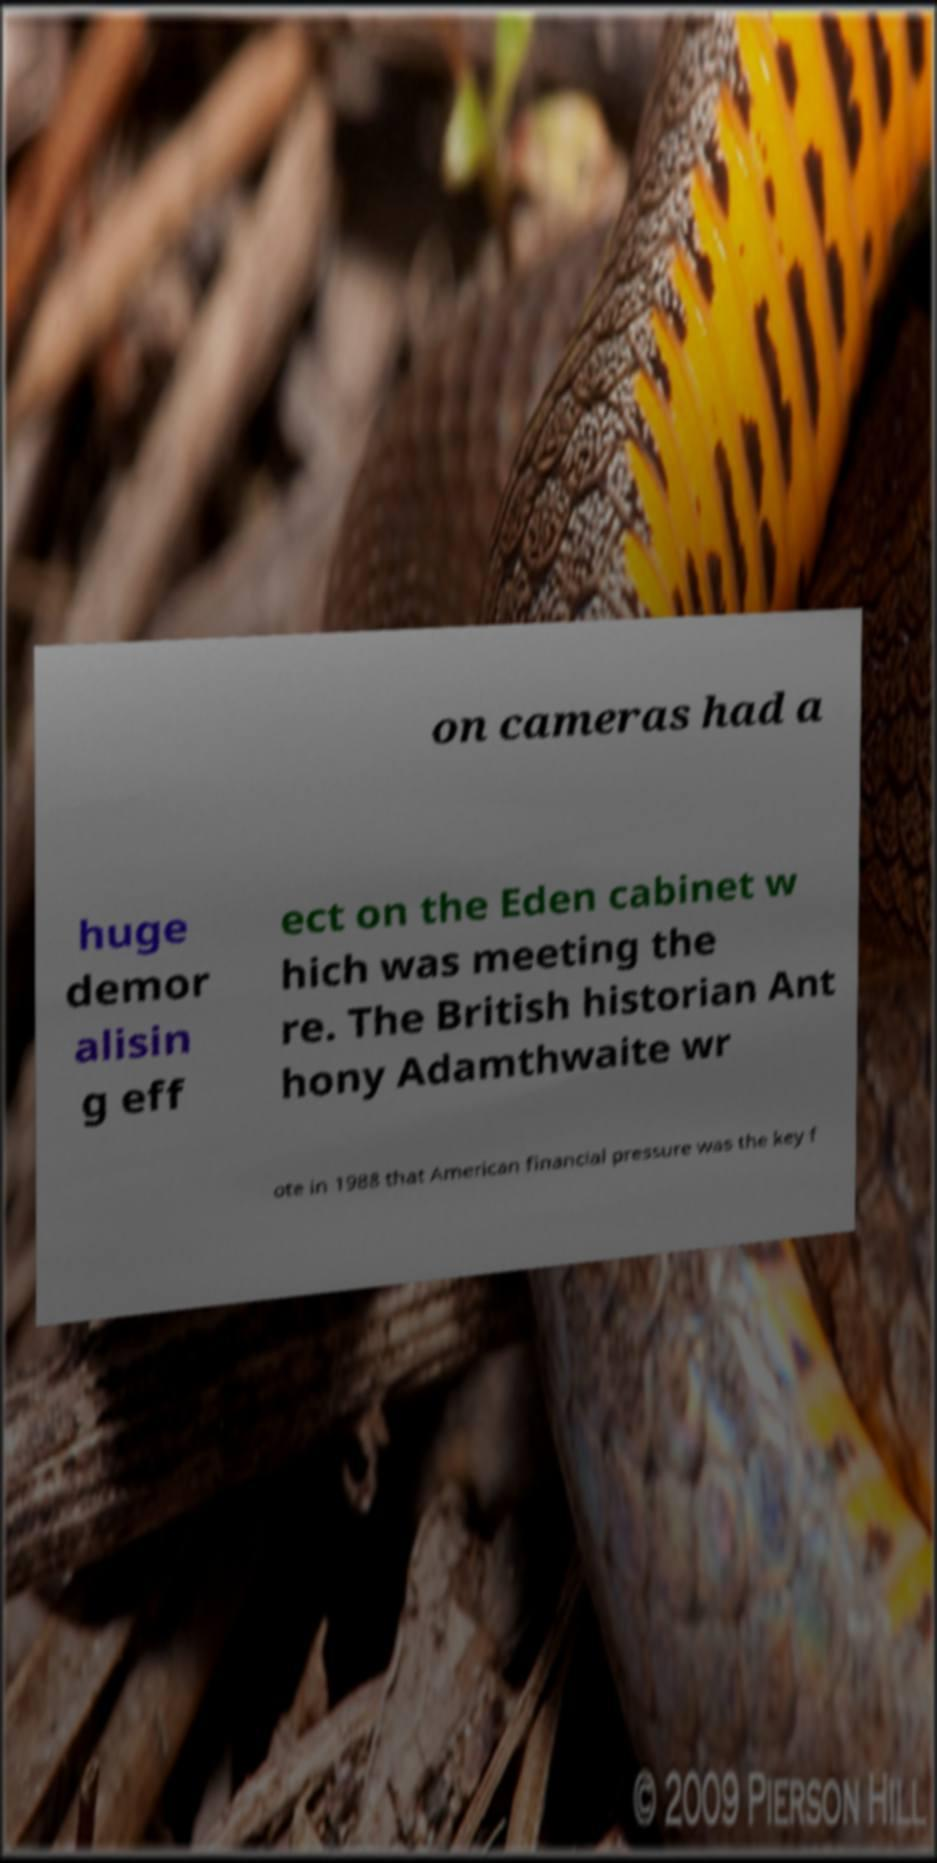There's text embedded in this image that I need extracted. Can you transcribe it verbatim? on cameras had a huge demor alisin g eff ect on the Eden cabinet w hich was meeting the re. The British historian Ant hony Adamthwaite wr ote in 1988 that American financial pressure was the key f 